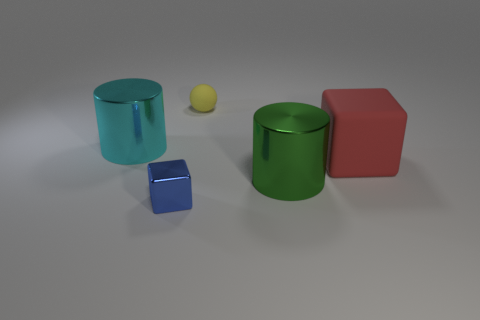Add 2 cyan cylinders. How many objects exist? 7 Subtract all red blocks. How many blocks are left? 1 Subtract all cubes. How many objects are left? 3 Subtract all yellow cubes. How many gray cylinders are left? 0 Subtract all small red balls. Subtract all cyan metal objects. How many objects are left? 4 Add 4 big cyan things. How many big cyan things are left? 5 Add 5 big cyan objects. How many big cyan objects exist? 6 Subtract 0 green blocks. How many objects are left? 5 Subtract all gray cubes. Subtract all purple cylinders. How many cubes are left? 2 